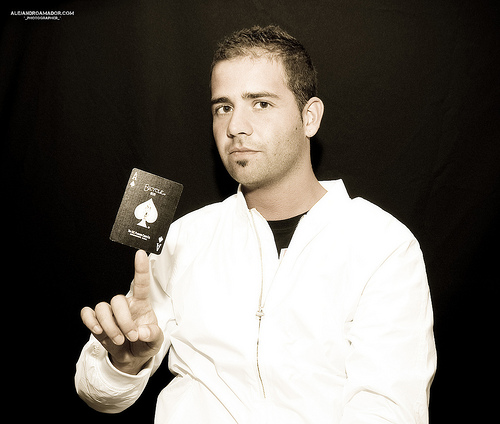<image>
Is there a card on the man? Yes. Looking at the image, I can see the card is positioned on top of the man, with the man providing support. 